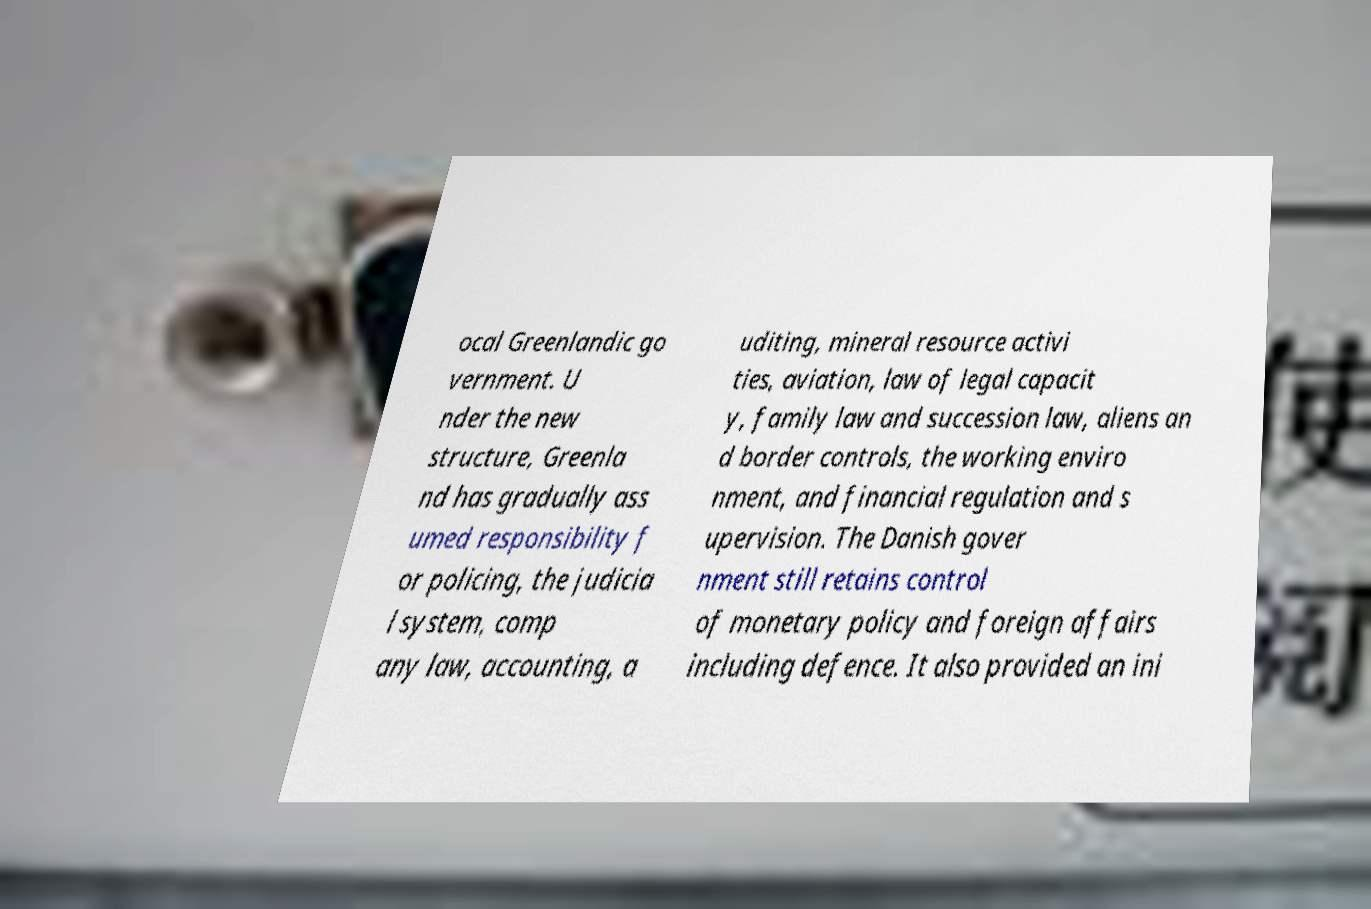Please identify and transcribe the text found in this image. ocal Greenlandic go vernment. U nder the new structure, Greenla nd has gradually ass umed responsibility f or policing, the judicia l system, comp any law, accounting, a uditing, mineral resource activi ties, aviation, law of legal capacit y, family law and succession law, aliens an d border controls, the working enviro nment, and financial regulation and s upervision. The Danish gover nment still retains control of monetary policy and foreign affairs including defence. It also provided an ini 